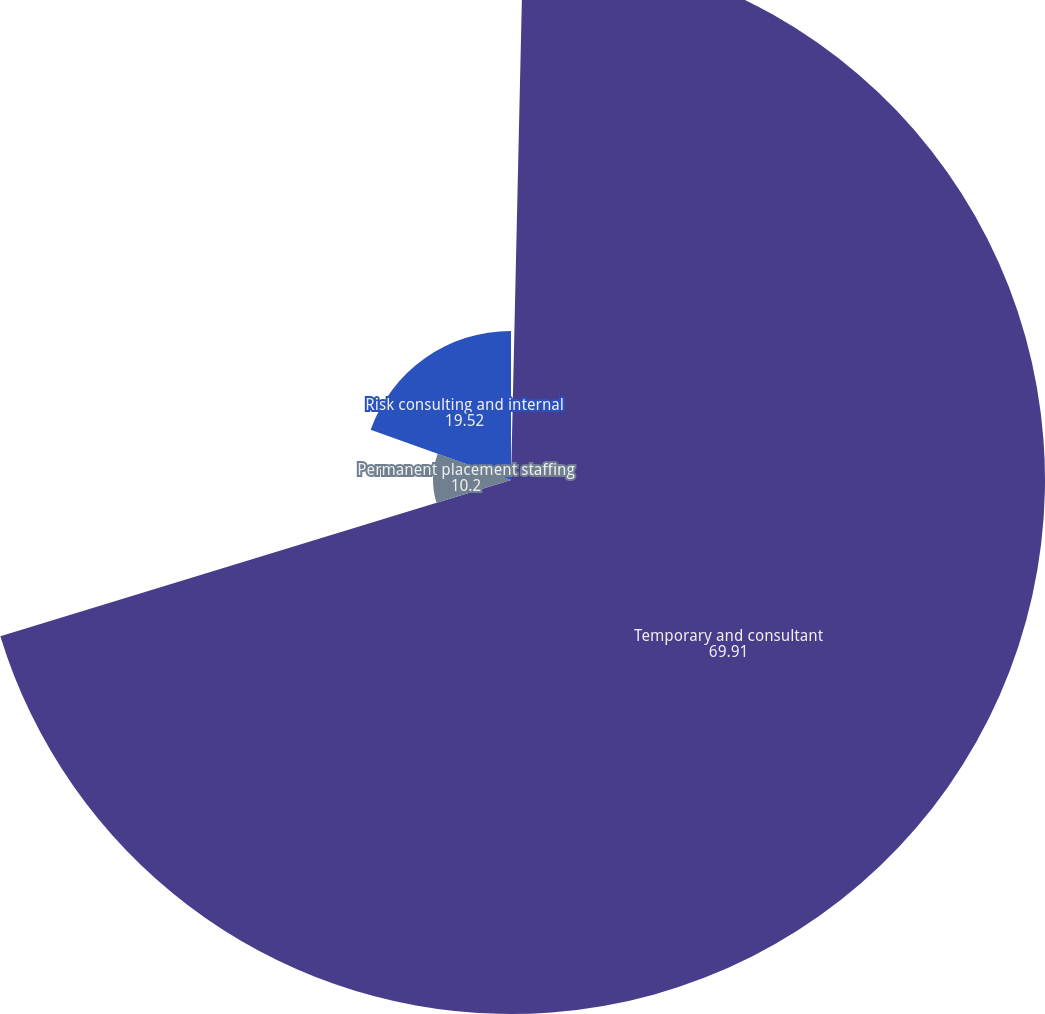Convert chart to OTSL. <chart><loc_0><loc_0><loc_500><loc_500><pie_chart><fcel>DECEMBER 31<fcel>Temporary and consultant<fcel>Permanent placement staffing<fcel>Risk consulting and internal<nl><fcel>0.36%<fcel>69.91%<fcel>10.2%<fcel>19.52%<nl></chart> 